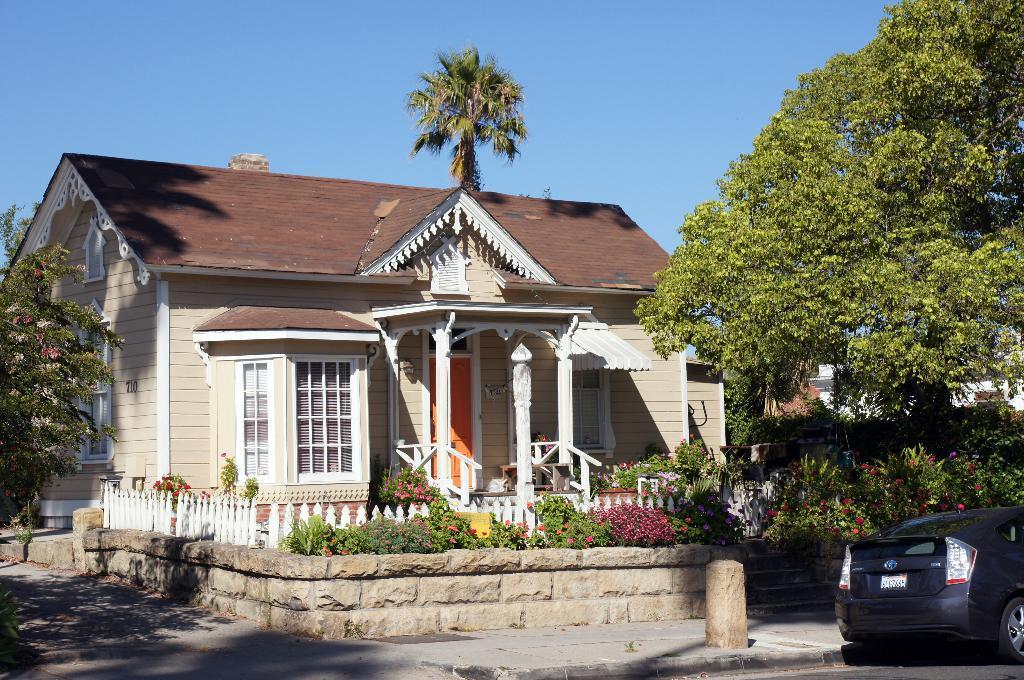Could you give a brief overview of what you see in this image? In this image I can see there is a house with stairs. And in front of the house there is a fence and there are plants with flowers. There is a road and on the road there is a car. Beside the house there are trees. And at the top there is a sky. 